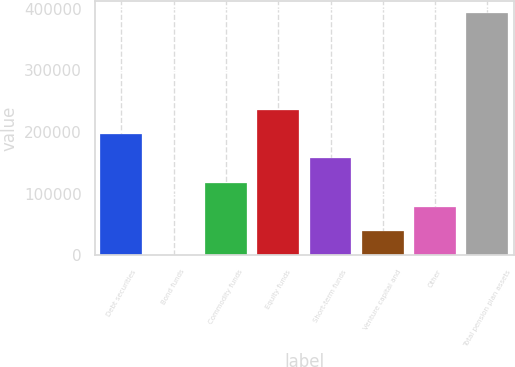Convert chart. <chart><loc_0><loc_0><loc_500><loc_500><bar_chart><fcel>Debt securities<fcel>Bond funds<fcel>Commodity funds<fcel>Equity funds<fcel>Short-term funds<fcel>Venture capital and<fcel>Other<fcel>Total pension plan assets<nl><fcel>196712<fcel>3<fcel>118029<fcel>236054<fcel>157371<fcel>39344.9<fcel>78686.8<fcel>393422<nl></chart> 